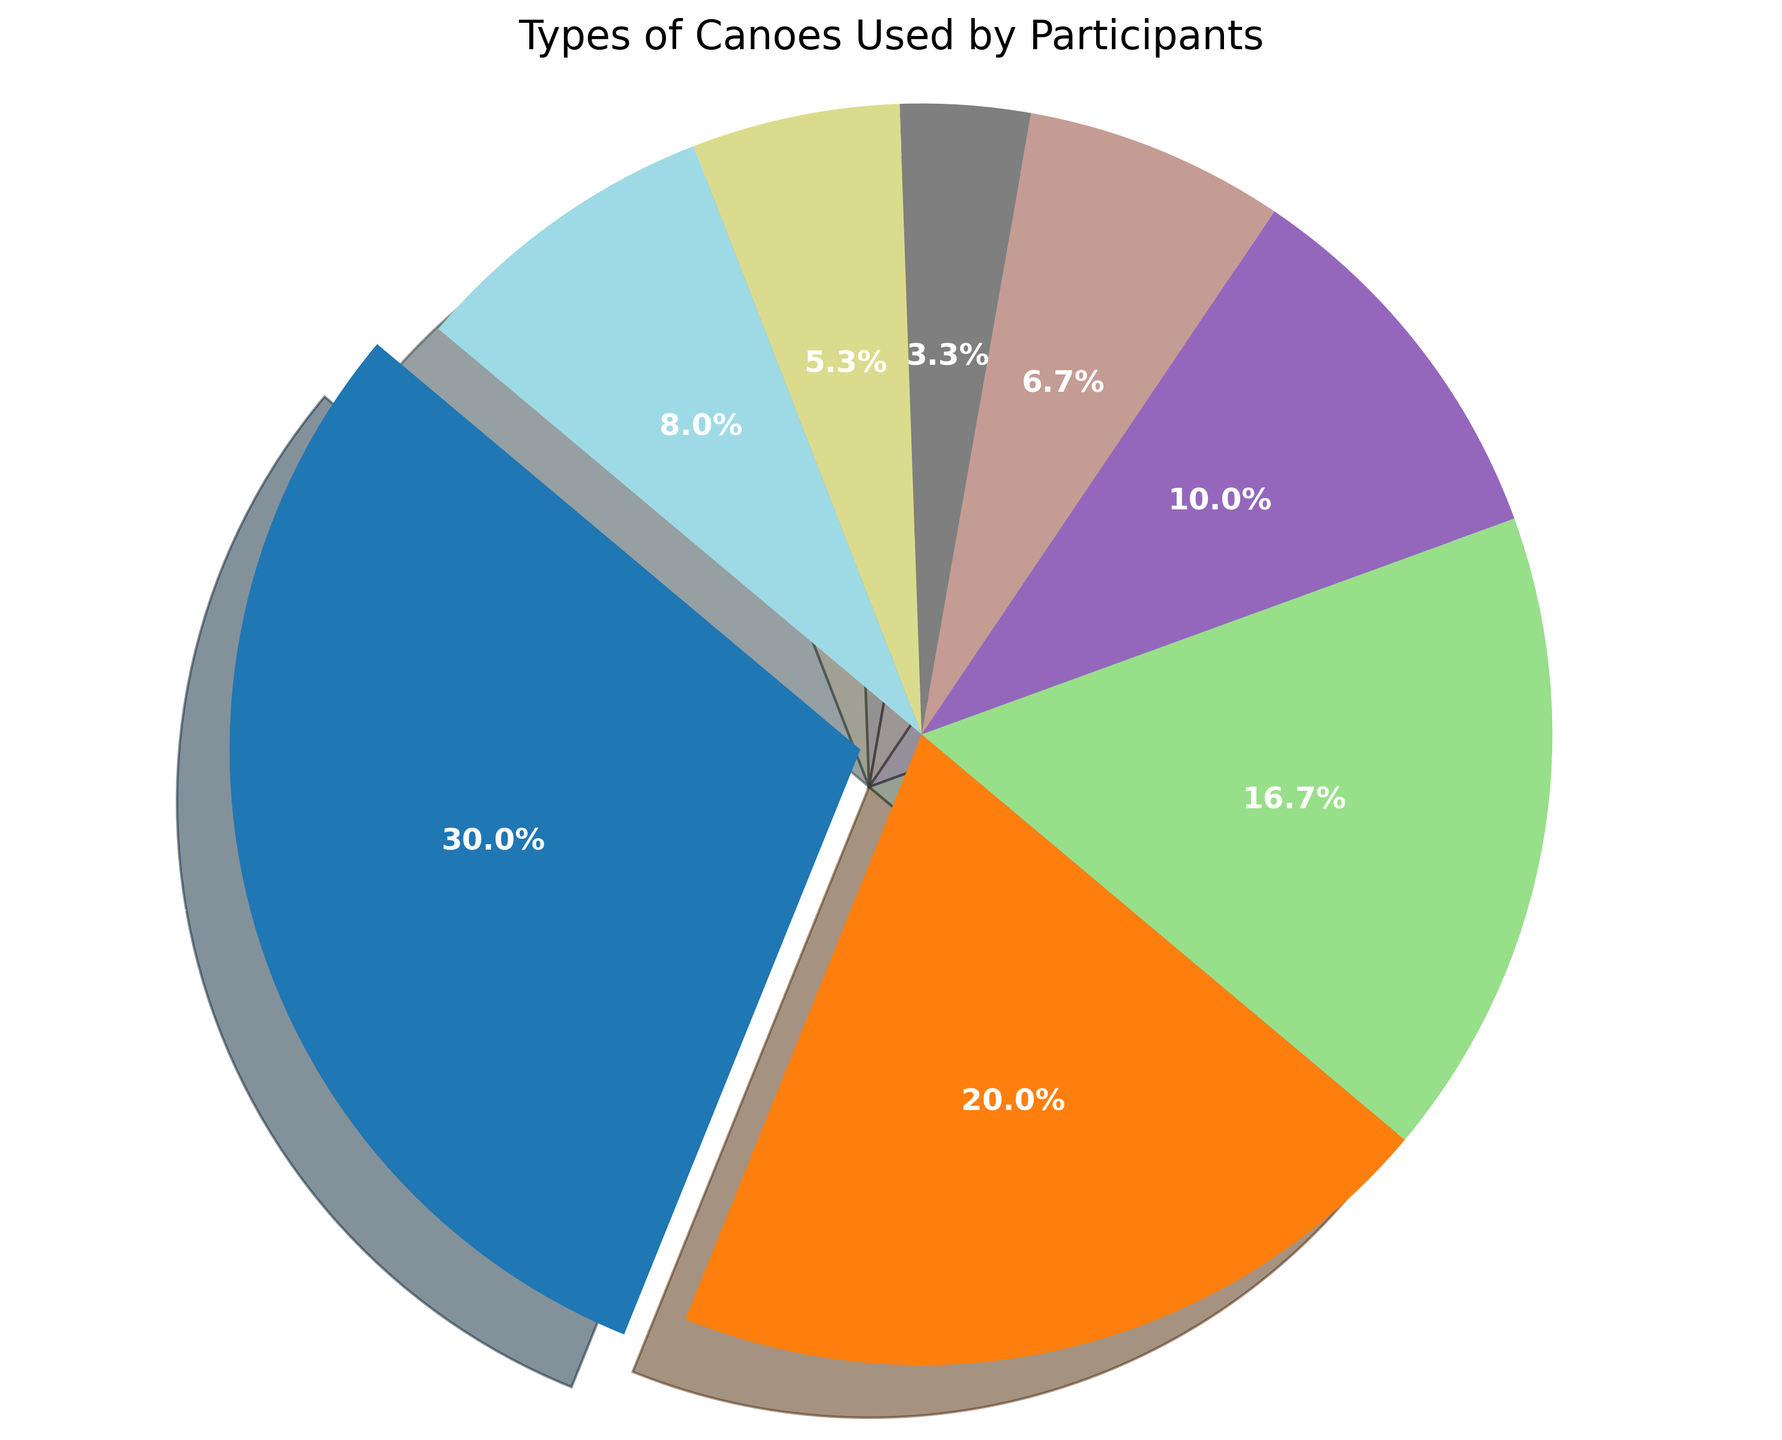What is the most common type of canoe used by participants? The pie chart shows the distribution of different types of canoes, with the largest section labeled as "Kayak" and occupying the biggest portion.
Answer: Kayak Which type of canoe is used least frequently? In the pie chart, the smallest section is labeled "Slalom," indicating that this type of canoe has the lowest count.
Answer: Slalom How many more participants use a Kayak than a C-1? The pie chart indicates that 45 participants use a Kayak, while 30 use a C-1. The difference is 45 - 30.
Answer: 15 Which is more popular, OC-1 or Touring? By comparing the sizes of the wedges, we see that OC-1 has a count of 15 and Touring has a count of 12. Therefore, OC-1 is more popular.
Answer: OC-1 What percentage of participants use either a C-1 or a C-2? The percentages of participants using C-1 and C-2 are shown on the pie chart as 30 and 25 respectively. Adding these values and finding the percentage, (30 + 25) / (45+30+25+15+10+5+8+12) * 100, gives the result.
Answer: 27.8% Which type of canoe has a visual segment colored in the first position? The pie chart begins with the lightest color, which is given to the largest segment "Kayak."
Answer: Kayak Calculate the total percentage of participants using OC-1 and OC-2 combined. The chart provides 15 participants for OC-1 and 10 for OC-2. Summing these and finding the percentage (15+10) / 150 * 100.
Answer: 16.7% Is the segment for Sprint larger or smaller than that for Touring? By visually comparing the segments, the pie chart shows that Touring has a larger portion compared to Sprint (Touring = 12, Sprint = 8).
Answer: Touring What is the cumulative percentage of participants using either a Kayak or any C-type canoe? The wedges for Kayak (45 participants), C-1 (30 participants), and C-2 (25 participants) are summed, then calculated as (45+30+25) / 150 * 100.
Answer: 66.7% Which type of canoe has the segment with the shadow effect applied most prominently in the chart? The pie chart's segment for Kayak is slightly exploded, making its shadow effect more prominent than the others.
Answer: Kayak 